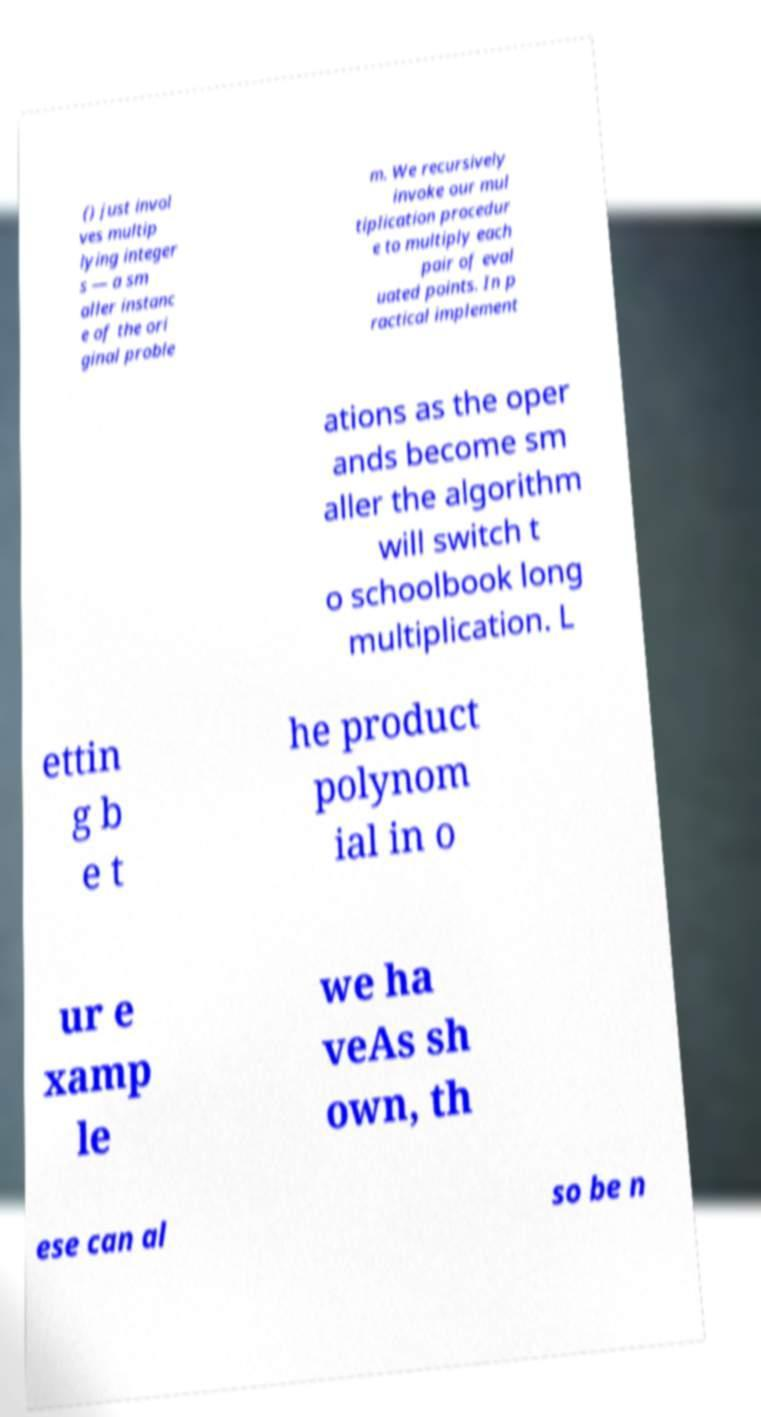There's text embedded in this image that I need extracted. Can you transcribe it verbatim? () just invol ves multip lying integer s — a sm aller instanc e of the ori ginal proble m. We recursively invoke our mul tiplication procedur e to multiply each pair of eval uated points. In p ractical implement ations as the oper ands become sm aller the algorithm will switch t o schoolbook long multiplication. L ettin g b e t he product polynom ial in o ur e xamp le we ha veAs sh own, th ese can al so be n 